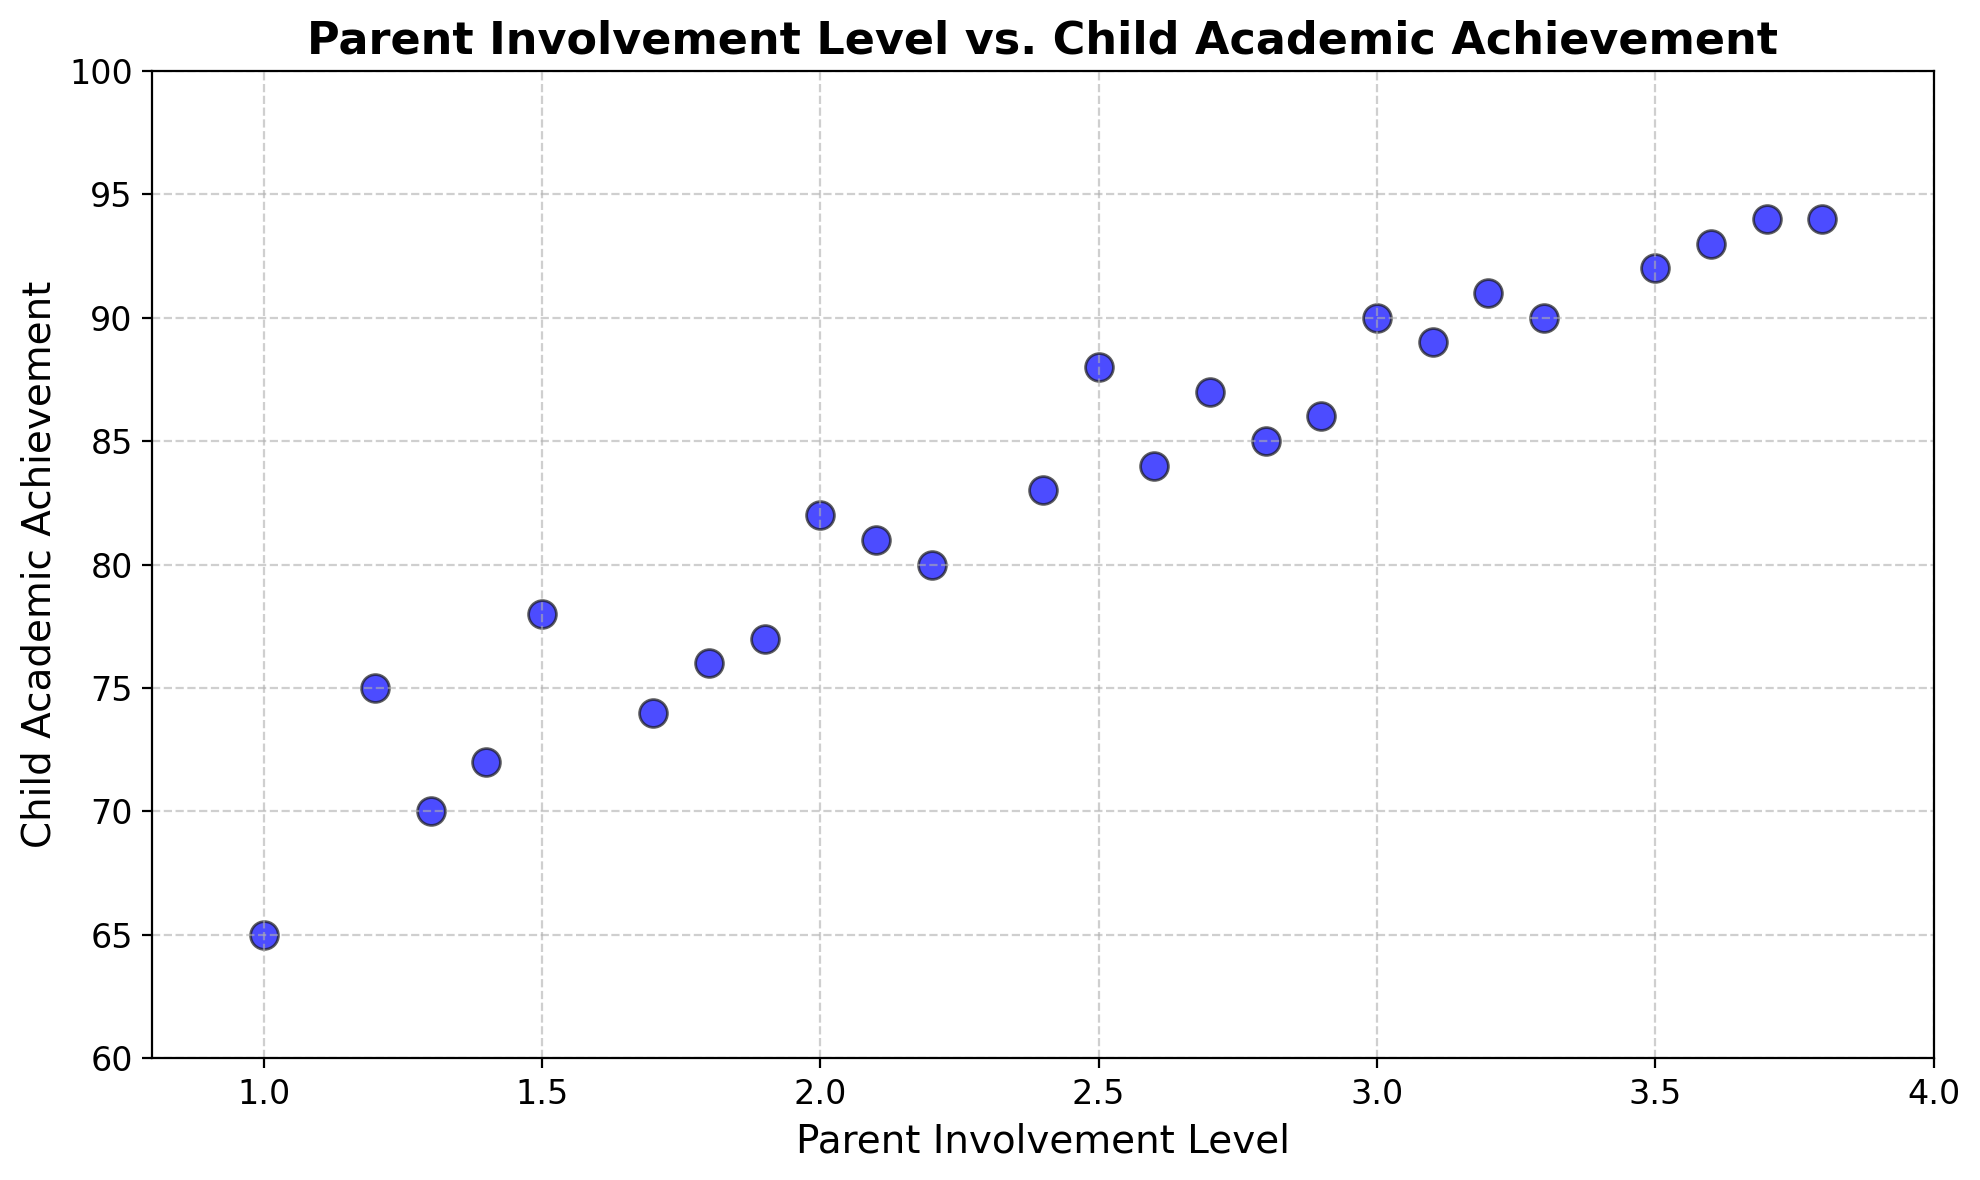What is the highest Child Academic Achievement score in the data? Look at the highest point on the y-axis, which represents Child Academic Achievement. The maximum value appears to be 94.
Answer: 94 What is the Parent Involvement Level for the student who scored the highest in Child Academic Achievement? Identify the point on the scatter plot with the highest Child Academic Achievement score (94), then read its corresponding Parent Involvement Level on the x-axis, which is 3.8.
Answer: 3.8 How many students had a Parent Involvement Level of 2.0 or greater? Count all the points on the scatter plot where the x-axis value (Parent Involvement Level) is equal to or greater than 2.0. We see 16 such points.
Answer: 16 What is the difference in Child Academic Achievement scores between students with the lowest and highest Parent Involvement Levels? First find the points with the lowest and highest Parent Involvement Levels (1.0 and 3.8, respectively). The corresponding Child Academic Achievement scores are 65 and 94. The difference is 94 - 65 = 29.
Answer: 29 Which student has a higher Child Academic Achievement score: a student with a Parent Involvement Level of 1.4 or one with 2.6? Compare the Child Academic Achievement scores corresponding to the Parent Involvement Levels of 1.4 and 2.6. The scores are 72 and 84, respectively. Thus, the student with 2.6 has a higher score.
Answer: Student with 2.6 Is there an observable trend between Parent Involvement Level and Child Academic Achievement? Observe the general direction of the points. As Parent Involvement Level increases along the x-axis, the Child Academic Achievement scores on the y-axis also tend to increase, suggesting a positive correlation.
Answer: Positive correlation What is the average Child Academic Achievement score for students with a Parent Involvement Level of 3.0 or higher? Identify the points with a Parent Involvement Level of 3.0 or higher, which are: (3.0, 90), (3.1, 89), (3.2, 91), (3.3, 90), (3.5, 92), (3.6, 93), (3.7, 94), (3.8, 94). Sum these Child Academic Achievement scores: 90 + 89 + 91 + 90 + 92 + 93 + 94 + 94 = 733. Divide by the number of points, 8: 733 / 8 = 91.625.
Answer: 91.625 Which two points have the closest Child Academic Achievement scores? Look for the two points with the smallest vertical distance (y-axis) between them. The points (3.0, 90) and (3.3, 90) both have a Child Academic Achievement score of 90.
Answer: (3.0, 90) and (3.3, 90) What is the range of Parent Involvement Levels in the data? Determine the smallest and largest values on the x-axis; the range is from 1.0 to 3.8.
Answer: 1.0 to 3.8 